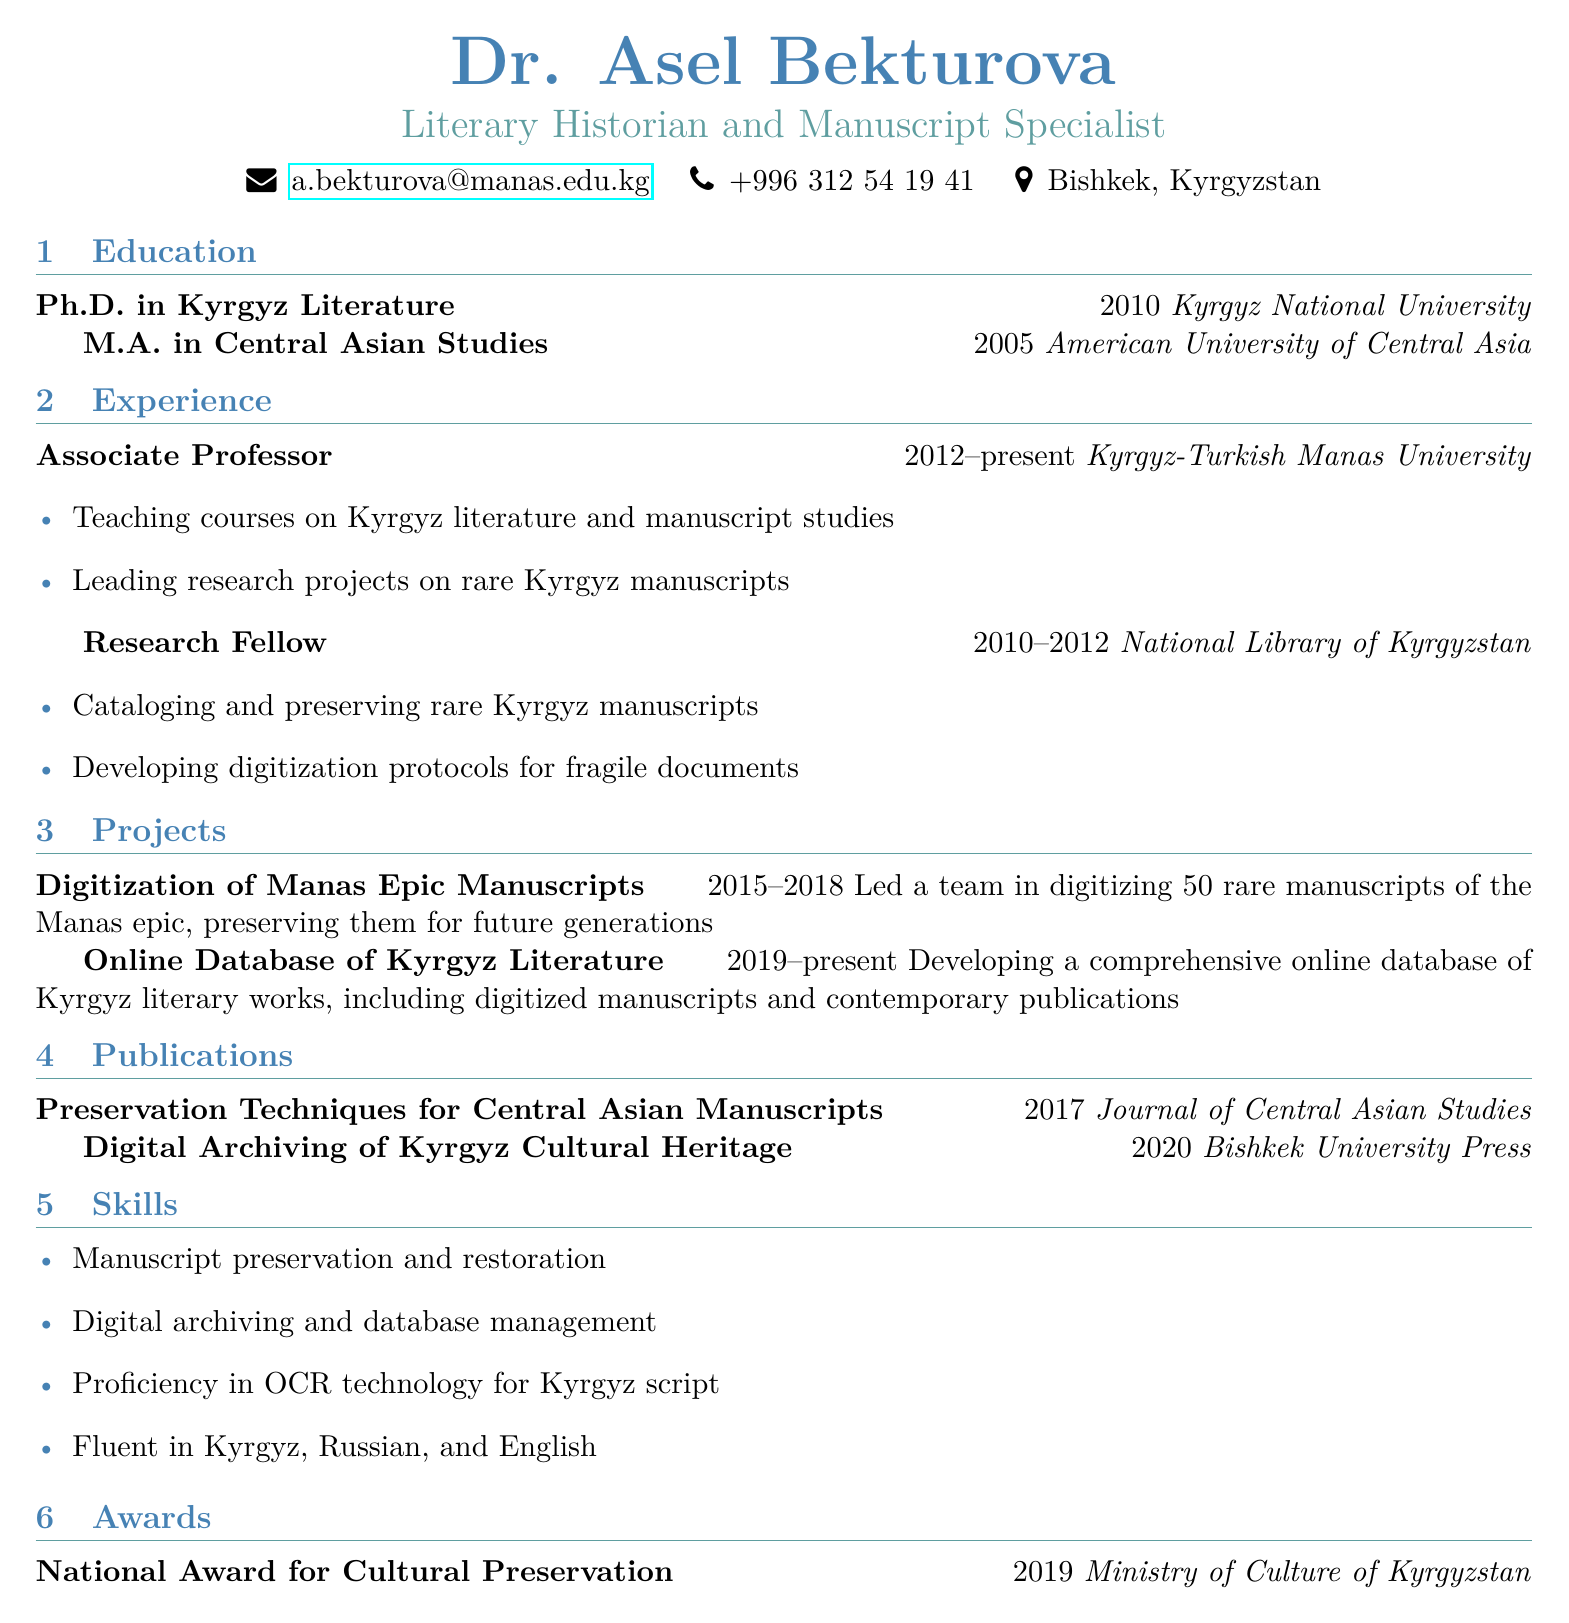What is Dr. Asel Bekturova's title? The title of Dr. Asel Bekturova is stated as "Literary Historian and Manuscript Specialist."
Answer: Literary Historian and Manuscript Specialist Where did Dr. Bekturova obtain her Ph.D.? The document specifies that she received her Ph.D. from Kyrgyz National University.
Answer: Kyrgyz National University What year did Dr. Bekturova start being an Associate Professor? The resume indicates she began her role as an Associate Professor in 2012.
Answer: 2012 How many rare manuscripts of the Manas epic were digitized in her project? The document states that 50 rare manuscripts of the Manas epic were digitized.
Answer: 50 Which award did Dr. Bekturova receive in 2019? The document lists that she received the National Award for Cultural Preservation in 2019.
Answer: National Award for Cultural Preservation What is the focus of the "Online Database of Kyrgyz Literature" project? This project is focused on developing a comprehensive online database of Kyrgyz literary works.
Answer: Developing a comprehensive online database What skills does Dr. Bekturova possess related to manuscript work? The resume lists "Manuscript preservation and restoration" as one of her skills.
Answer: Manuscript preservation and restoration In which journal was Dr. Bekturova's publication on preservation techniques published? According to the document, her publication was in the Journal of Central Asian Studies.
Answer: Journal of Central Asian Studies What years did Dr. Bekturova work as a Research Fellow? The document states that she worked as a Research Fellow from 2010 to 2012.
Answer: 2010-2012 